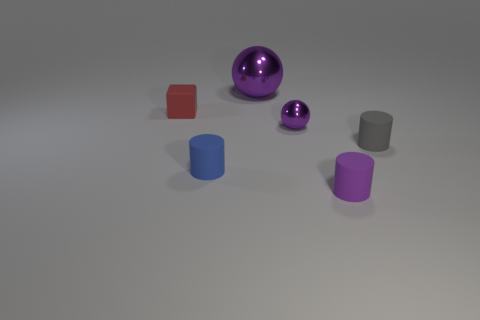Add 3 metal balls. How many objects exist? 9 Subtract all balls. How many objects are left? 4 Subtract 0 gray blocks. How many objects are left? 6 Subtract all brown metal cylinders. Subtract all cylinders. How many objects are left? 3 Add 3 gray rubber objects. How many gray rubber objects are left? 4 Add 5 tiny green cylinders. How many tiny green cylinders exist? 5 